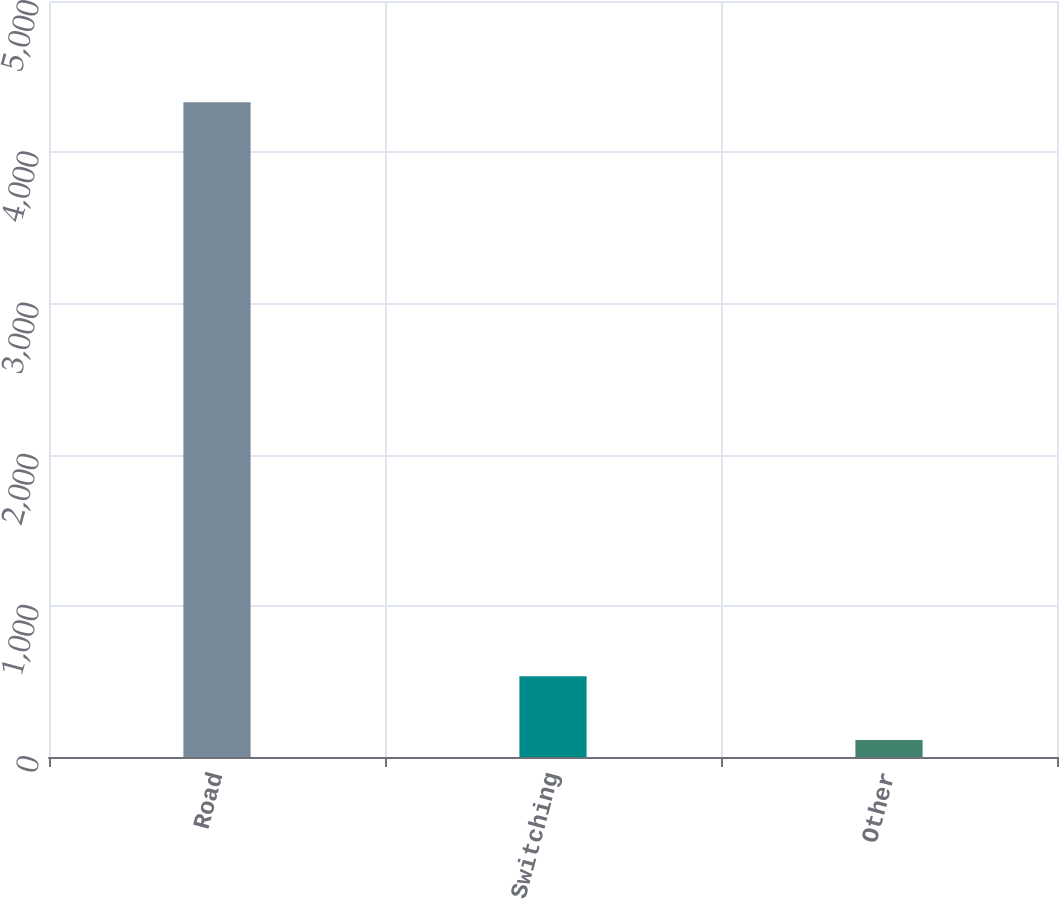Convert chart. <chart><loc_0><loc_0><loc_500><loc_500><bar_chart><fcel>Road<fcel>Switching<fcel>Other<nl><fcel>4330<fcel>533.8<fcel>112<nl></chart> 